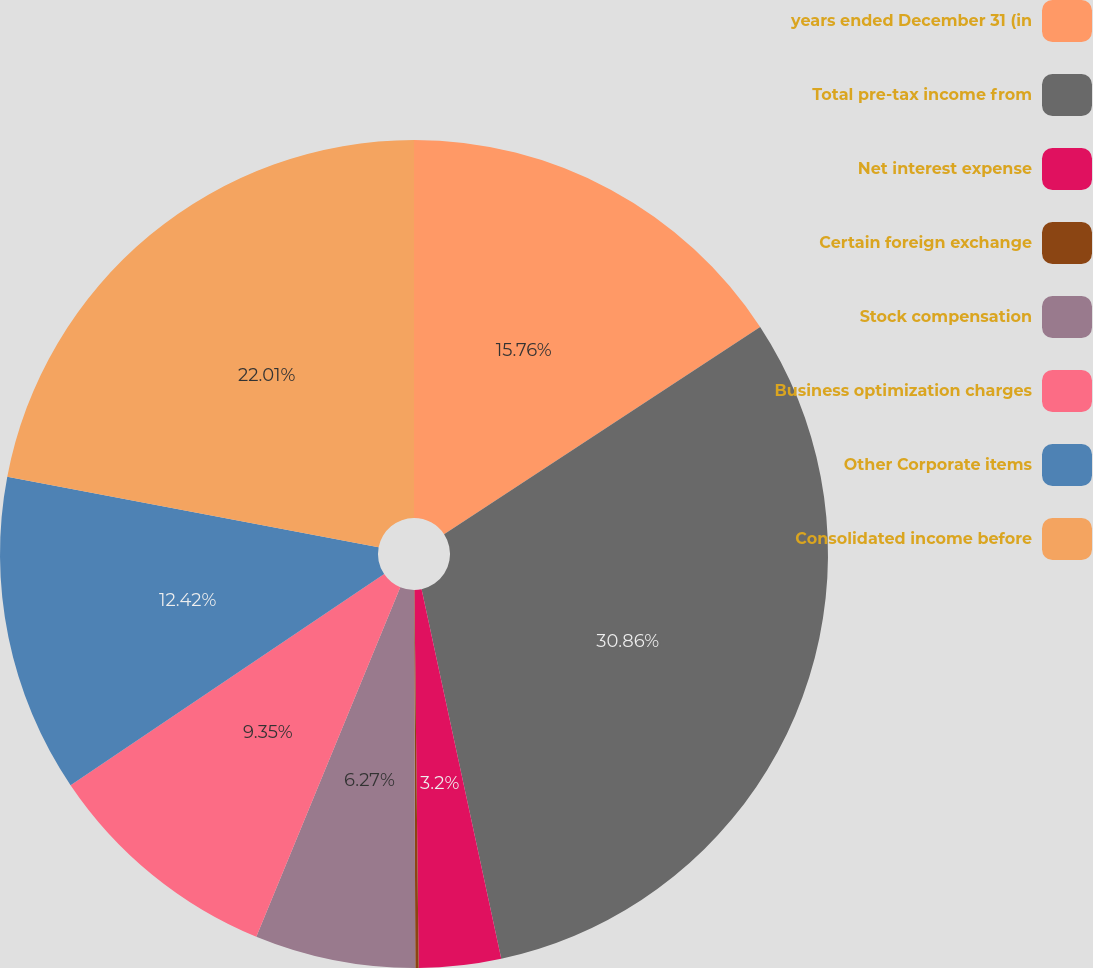Convert chart. <chart><loc_0><loc_0><loc_500><loc_500><pie_chart><fcel>years ended December 31 (in<fcel>Total pre-tax income from<fcel>Net interest expense<fcel>Certain foreign exchange<fcel>Stock compensation<fcel>Business optimization charges<fcel>Other Corporate items<fcel>Consolidated income before<nl><fcel>15.76%<fcel>30.86%<fcel>3.2%<fcel>0.13%<fcel>6.27%<fcel>9.35%<fcel>12.42%<fcel>22.01%<nl></chart> 